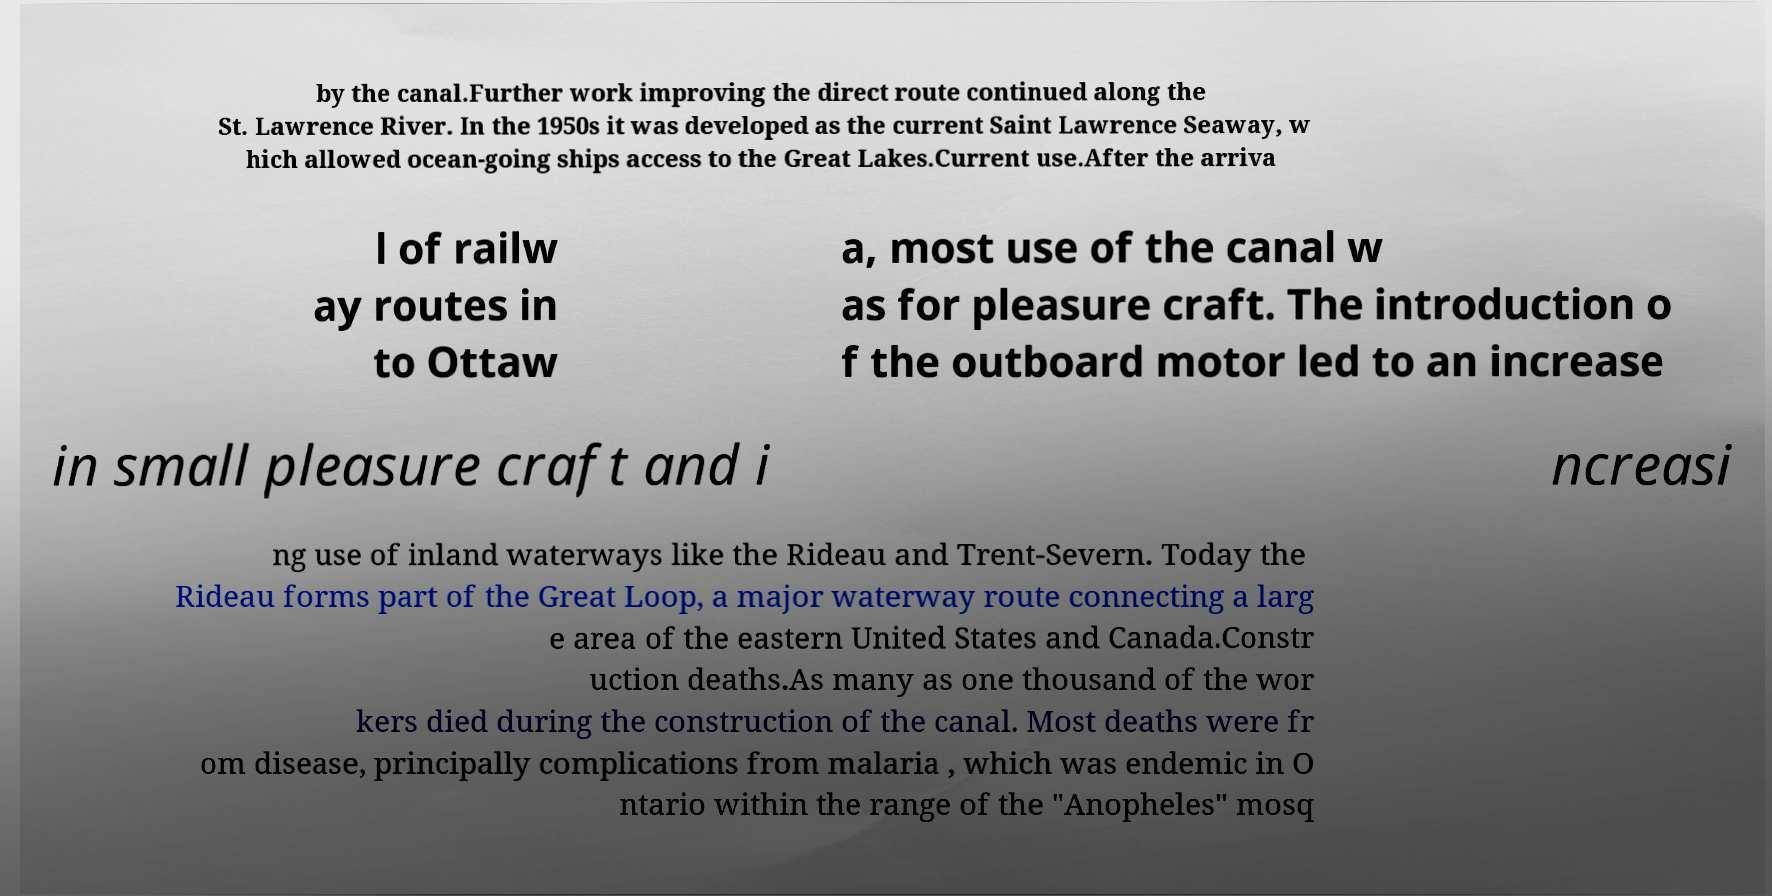For documentation purposes, I need the text within this image transcribed. Could you provide that? by the canal.Further work improving the direct route continued along the St. Lawrence River. In the 1950s it was developed as the current Saint Lawrence Seaway, w hich allowed ocean-going ships access to the Great Lakes.Current use.After the arriva l of railw ay routes in to Ottaw a, most use of the canal w as for pleasure craft. The introduction o f the outboard motor led to an increase in small pleasure craft and i ncreasi ng use of inland waterways like the Rideau and Trent-Severn. Today the Rideau forms part of the Great Loop, a major waterway route connecting a larg e area of the eastern United States and Canada.Constr uction deaths.As many as one thousand of the wor kers died during the construction of the canal. Most deaths were fr om disease, principally complications from malaria , which was endemic in O ntario within the range of the "Anopheles" mosq 